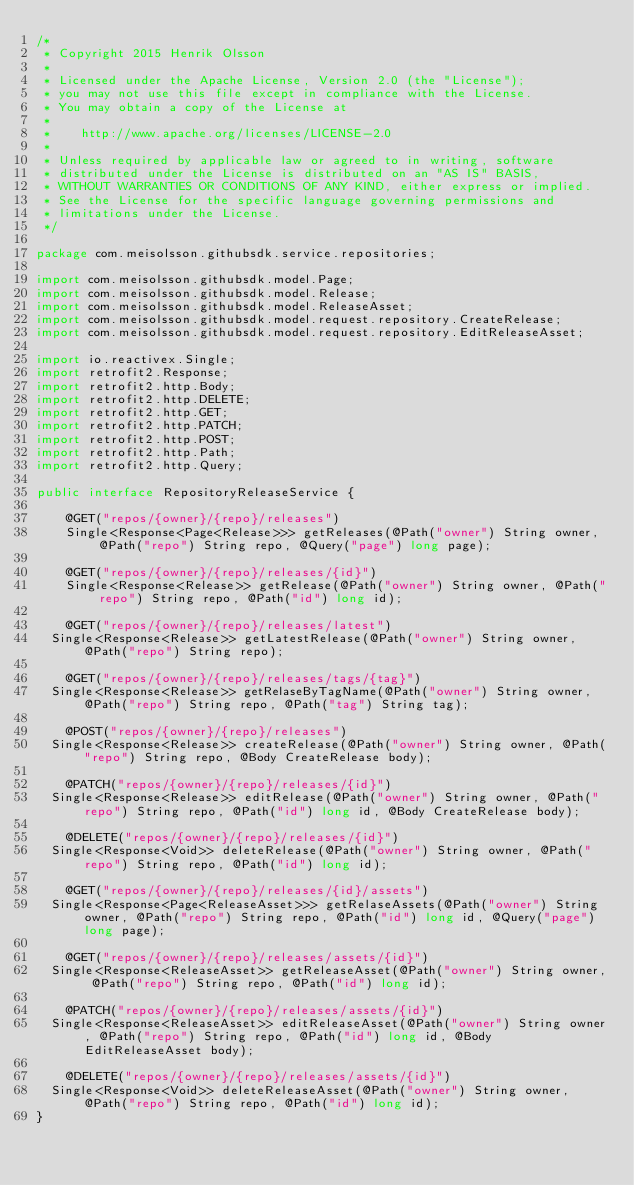Convert code to text. <code><loc_0><loc_0><loc_500><loc_500><_Java_>/*
 * Copyright 2015 Henrik Olsson
 *
 * Licensed under the Apache License, Version 2.0 (the "License");
 * you may not use this file except in compliance with the License.
 * You may obtain a copy of the License at
 *
 *    http://www.apache.org/licenses/LICENSE-2.0
 *
 * Unless required by applicable law or agreed to in writing, software
 * distributed under the License is distributed on an "AS IS" BASIS,
 * WITHOUT WARRANTIES OR CONDITIONS OF ANY KIND, either express or implied.
 * See the License for the specific language governing permissions and
 * limitations under the License.
 */

package com.meisolsson.githubsdk.service.repositories;

import com.meisolsson.githubsdk.model.Page;
import com.meisolsson.githubsdk.model.Release;
import com.meisolsson.githubsdk.model.ReleaseAsset;
import com.meisolsson.githubsdk.model.request.repository.CreateRelease;
import com.meisolsson.githubsdk.model.request.repository.EditReleaseAsset;

import io.reactivex.Single;
import retrofit2.Response;
import retrofit2.http.Body;
import retrofit2.http.DELETE;
import retrofit2.http.GET;
import retrofit2.http.PATCH;
import retrofit2.http.POST;
import retrofit2.http.Path;
import retrofit2.http.Query;

public interface RepositoryReleaseService {

    @GET("repos/{owner}/{repo}/releases")
    Single<Response<Page<Release>>> getReleases(@Path("owner") String owner, @Path("repo") String repo, @Query("page") long page);

    @GET("repos/{owner}/{repo}/releases/{id}")
    Single<Response<Release>> getRelease(@Path("owner") String owner, @Path("repo") String repo, @Path("id") long id);

    @GET("repos/{owner}/{repo}/releases/latest")
	Single<Response<Release>> getLatestRelease(@Path("owner") String owner, @Path("repo") String repo);

    @GET("repos/{owner}/{repo}/releases/tags/{tag}")
	Single<Response<Release>> getRelaseByTagName(@Path("owner") String owner, @Path("repo") String repo, @Path("tag") String tag);

    @POST("repos/{owner}/{repo}/releases")
	Single<Response<Release>> createRelease(@Path("owner") String owner, @Path("repo") String repo, @Body CreateRelease body);

    @PATCH("repos/{owner}/{repo}/releases/{id}")
	Single<Response<Release>> editRelease(@Path("owner") String owner, @Path("repo") String repo, @Path("id") long id, @Body CreateRelease body);

    @DELETE("repos/{owner}/{repo}/releases/{id}")
	Single<Response<Void>> deleteRelease(@Path("owner") String owner, @Path("repo") String repo, @Path("id") long id);

    @GET("repos/{owner}/{repo}/releases/{id}/assets")
	Single<Response<Page<ReleaseAsset>>> getRelaseAssets(@Path("owner") String owner, @Path("repo") String repo, @Path("id") long id, @Query("page") long page);

    @GET("repos/{owner}/{repo}/releases/assets/{id}")
	Single<Response<ReleaseAsset>> getReleaseAsset(@Path("owner") String owner, @Path("repo") String repo, @Path("id") long id);

    @PATCH("repos/{owner}/{repo}/releases/assets/{id}")
	Single<Response<ReleaseAsset>> editReleaseAsset(@Path("owner") String owner, @Path("repo") String repo, @Path("id") long id, @Body EditReleaseAsset body);

    @DELETE("repos/{owner}/{repo}/releases/assets/{id}")
	Single<Response<Void>> deleteReleaseAsset(@Path("owner") String owner, @Path("repo") String repo, @Path("id") long id);
}
</code> 